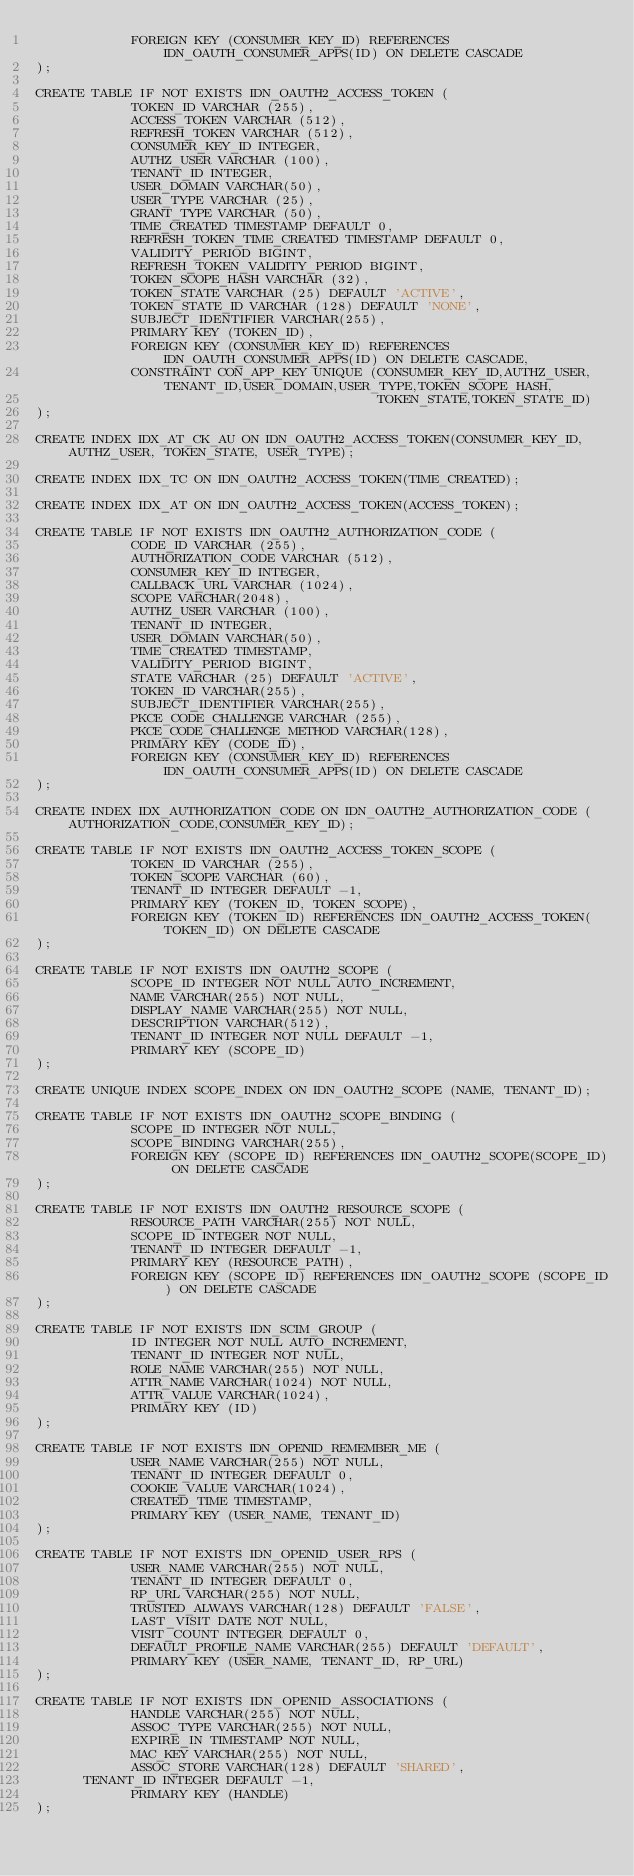Convert code to text. <code><loc_0><loc_0><loc_500><loc_500><_SQL_>            FOREIGN KEY (CONSUMER_KEY_ID) REFERENCES IDN_OAUTH_CONSUMER_APPS(ID) ON DELETE CASCADE
);

CREATE TABLE IF NOT EXISTS IDN_OAUTH2_ACCESS_TOKEN (
            TOKEN_ID VARCHAR (255),
            ACCESS_TOKEN VARCHAR (512),
            REFRESH_TOKEN VARCHAR (512),
            CONSUMER_KEY_ID INTEGER,
            AUTHZ_USER VARCHAR (100),
            TENANT_ID INTEGER,
            USER_DOMAIN VARCHAR(50),
            USER_TYPE VARCHAR (25),
            GRANT_TYPE VARCHAR (50),
            TIME_CREATED TIMESTAMP DEFAULT 0,
            REFRESH_TOKEN_TIME_CREATED TIMESTAMP DEFAULT 0,
            VALIDITY_PERIOD BIGINT,
            REFRESH_TOKEN_VALIDITY_PERIOD BIGINT,
            TOKEN_SCOPE_HASH VARCHAR (32),
            TOKEN_STATE VARCHAR (25) DEFAULT 'ACTIVE',
            TOKEN_STATE_ID VARCHAR (128) DEFAULT 'NONE',
            SUBJECT_IDENTIFIER VARCHAR(255),
            PRIMARY KEY (TOKEN_ID),
            FOREIGN KEY (CONSUMER_KEY_ID) REFERENCES IDN_OAUTH_CONSUMER_APPS(ID) ON DELETE CASCADE,
            CONSTRAINT CON_APP_KEY UNIQUE (CONSUMER_KEY_ID,AUTHZ_USER,TENANT_ID,USER_DOMAIN,USER_TYPE,TOKEN_SCOPE_HASH,
                                           TOKEN_STATE,TOKEN_STATE_ID)
);

CREATE INDEX IDX_AT_CK_AU ON IDN_OAUTH2_ACCESS_TOKEN(CONSUMER_KEY_ID, AUTHZ_USER, TOKEN_STATE, USER_TYPE);

CREATE INDEX IDX_TC ON IDN_OAUTH2_ACCESS_TOKEN(TIME_CREATED);

CREATE INDEX IDX_AT ON IDN_OAUTH2_ACCESS_TOKEN(ACCESS_TOKEN);

CREATE TABLE IF NOT EXISTS IDN_OAUTH2_AUTHORIZATION_CODE (
            CODE_ID VARCHAR (255),
            AUTHORIZATION_CODE VARCHAR (512),
            CONSUMER_KEY_ID INTEGER,
            CALLBACK_URL VARCHAR (1024),
            SCOPE VARCHAR(2048),
            AUTHZ_USER VARCHAR (100),
            TENANT_ID INTEGER,
            USER_DOMAIN VARCHAR(50),
            TIME_CREATED TIMESTAMP,
            VALIDITY_PERIOD BIGINT,
            STATE VARCHAR (25) DEFAULT 'ACTIVE',
            TOKEN_ID VARCHAR(255),
            SUBJECT_IDENTIFIER VARCHAR(255),
            PKCE_CODE_CHALLENGE VARCHAR (255),
            PKCE_CODE_CHALLENGE_METHOD VARCHAR(128),
            PRIMARY KEY (CODE_ID),
            FOREIGN KEY (CONSUMER_KEY_ID) REFERENCES IDN_OAUTH_CONSUMER_APPS(ID) ON DELETE CASCADE
);

CREATE INDEX IDX_AUTHORIZATION_CODE ON IDN_OAUTH2_AUTHORIZATION_CODE (AUTHORIZATION_CODE,CONSUMER_KEY_ID);

CREATE TABLE IF NOT EXISTS IDN_OAUTH2_ACCESS_TOKEN_SCOPE (
            TOKEN_ID VARCHAR (255),
            TOKEN_SCOPE VARCHAR (60),
            TENANT_ID INTEGER DEFAULT -1,
            PRIMARY KEY (TOKEN_ID, TOKEN_SCOPE),
            FOREIGN KEY (TOKEN_ID) REFERENCES IDN_OAUTH2_ACCESS_TOKEN(TOKEN_ID) ON DELETE CASCADE
);

CREATE TABLE IF NOT EXISTS IDN_OAUTH2_SCOPE (
            SCOPE_ID INTEGER NOT NULL AUTO_INCREMENT,
            NAME VARCHAR(255) NOT NULL,
            DISPLAY_NAME VARCHAR(255) NOT NULL,
            DESCRIPTION VARCHAR(512),
            TENANT_ID INTEGER NOT NULL DEFAULT -1,
            PRIMARY KEY (SCOPE_ID)
);

CREATE UNIQUE INDEX SCOPE_INDEX ON IDN_OAUTH2_SCOPE (NAME, TENANT_ID);

CREATE TABLE IF NOT EXISTS IDN_OAUTH2_SCOPE_BINDING (
            SCOPE_ID INTEGER NOT NULL,
            SCOPE_BINDING VARCHAR(255),
            FOREIGN KEY (SCOPE_ID) REFERENCES IDN_OAUTH2_SCOPE(SCOPE_ID) ON DELETE CASCADE
);

CREATE TABLE IF NOT EXISTS IDN_OAUTH2_RESOURCE_SCOPE (
            RESOURCE_PATH VARCHAR(255) NOT NULL,
            SCOPE_ID INTEGER NOT NULL,
            TENANT_ID INTEGER DEFAULT -1,
            PRIMARY KEY (RESOURCE_PATH),
            FOREIGN KEY (SCOPE_ID) REFERENCES IDN_OAUTH2_SCOPE (SCOPE_ID) ON DELETE CASCADE
);

CREATE TABLE IF NOT EXISTS IDN_SCIM_GROUP (
            ID INTEGER NOT NULL AUTO_INCREMENT,
            TENANT_ID INTEGER NOT NULL,
            ROLE_NAME VARCHAR(255) NOT NULL,
            ATTR_NAME VARCHAR(1024) NOT NULL,
            ATTR_VALUE VARCHAR(1024),
            PRIMARY KEY (ID)
);

CREATE TABLE IF NOT EXISTS IDN_OPENID_REMEMBER_ME (
            USER_NAME VARCHAR(255) NOT NULL,
            TENANT_ID INTEGER DEFAULT 0,
            COOKIE_VALUE VARCHAR(1024),
            CREATED_TIME TIMESTAMP,
            PRIMARY KEY (USER_NAME, TENANT_ID)
);

CREATE TABLE IF NOT EXISTS IDN_OPENID_USER_RPS (
			USER_NAME VARCHAR(255) NOT NULL,
			TENANT_ID INTEGER DEFAULT 0,
			RP_URL VARCHAR(255) NOT NULL,
			TRUSTED_ALWAYS VARCHAR(128) DEFAULT 'FALSE',
			LAST_VISIT DATE NOT NULL,
			VISIT_COUNT INTEGER DEFAULT 0,
			DEFAULT_PROFILE_NAME VARCHAR(255) DEFAULT 'DEFAULT',
			PRIMARY KEY (USER_NAME, TENANT_ID, RP_URL)
);

CREATE TABLE IF NOT EXISTS IDN_OPENID_ASSOCIATIONS (
			HANDLE VARCHAR(255) NOT NULL,
			ASSOC_TYPE VARCHAR(255) NOT NULL,
			EXPIRE_IN TIMESTAMP NOT NULL,
			MAC_KEY VARCHAR(255) NOT NULL,
			ASSOC_STORE VARCHAR(128) DEFAULT 'SHARED',
      TENANT_ID INTEGER DEFAULT -1,
			PRIMARY KEY (HANDLE)
);
</code> 